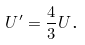<formula> <loc_0><loc_0><loc_500><loc_500>U ^ { \prime } = \frac { 4 } { 3 } U \text {.}</formula> 